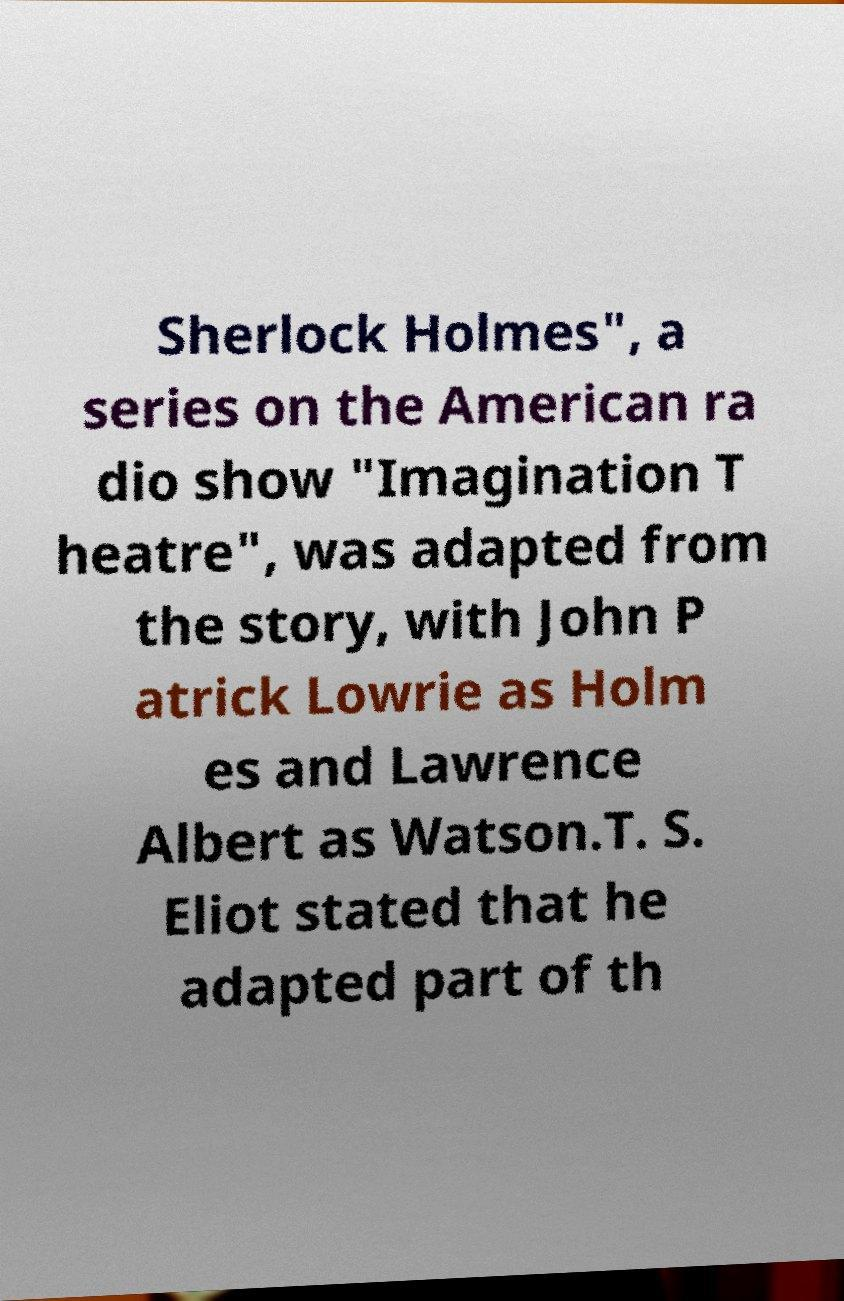Can you read and provide the text displayed in the image?This photo seems to have some interesting text. Can you extract and type it out for me? Sherlock Holmes", a series on the American ra dio show "Imagination T heatre", was adapted from the story, with John P atrick Lowrie as Holm es and Lawrence Albert as Watson.T. S. Eliot stated that he adapted part of th 